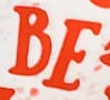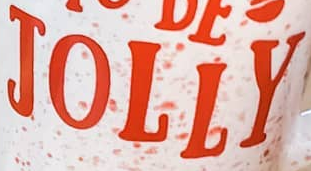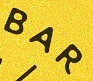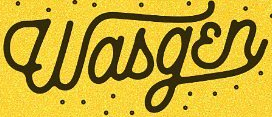What text is displayed in these images sequentially, separated by a semicolon? BE; JOLLY; BAR; Wasgɛn 